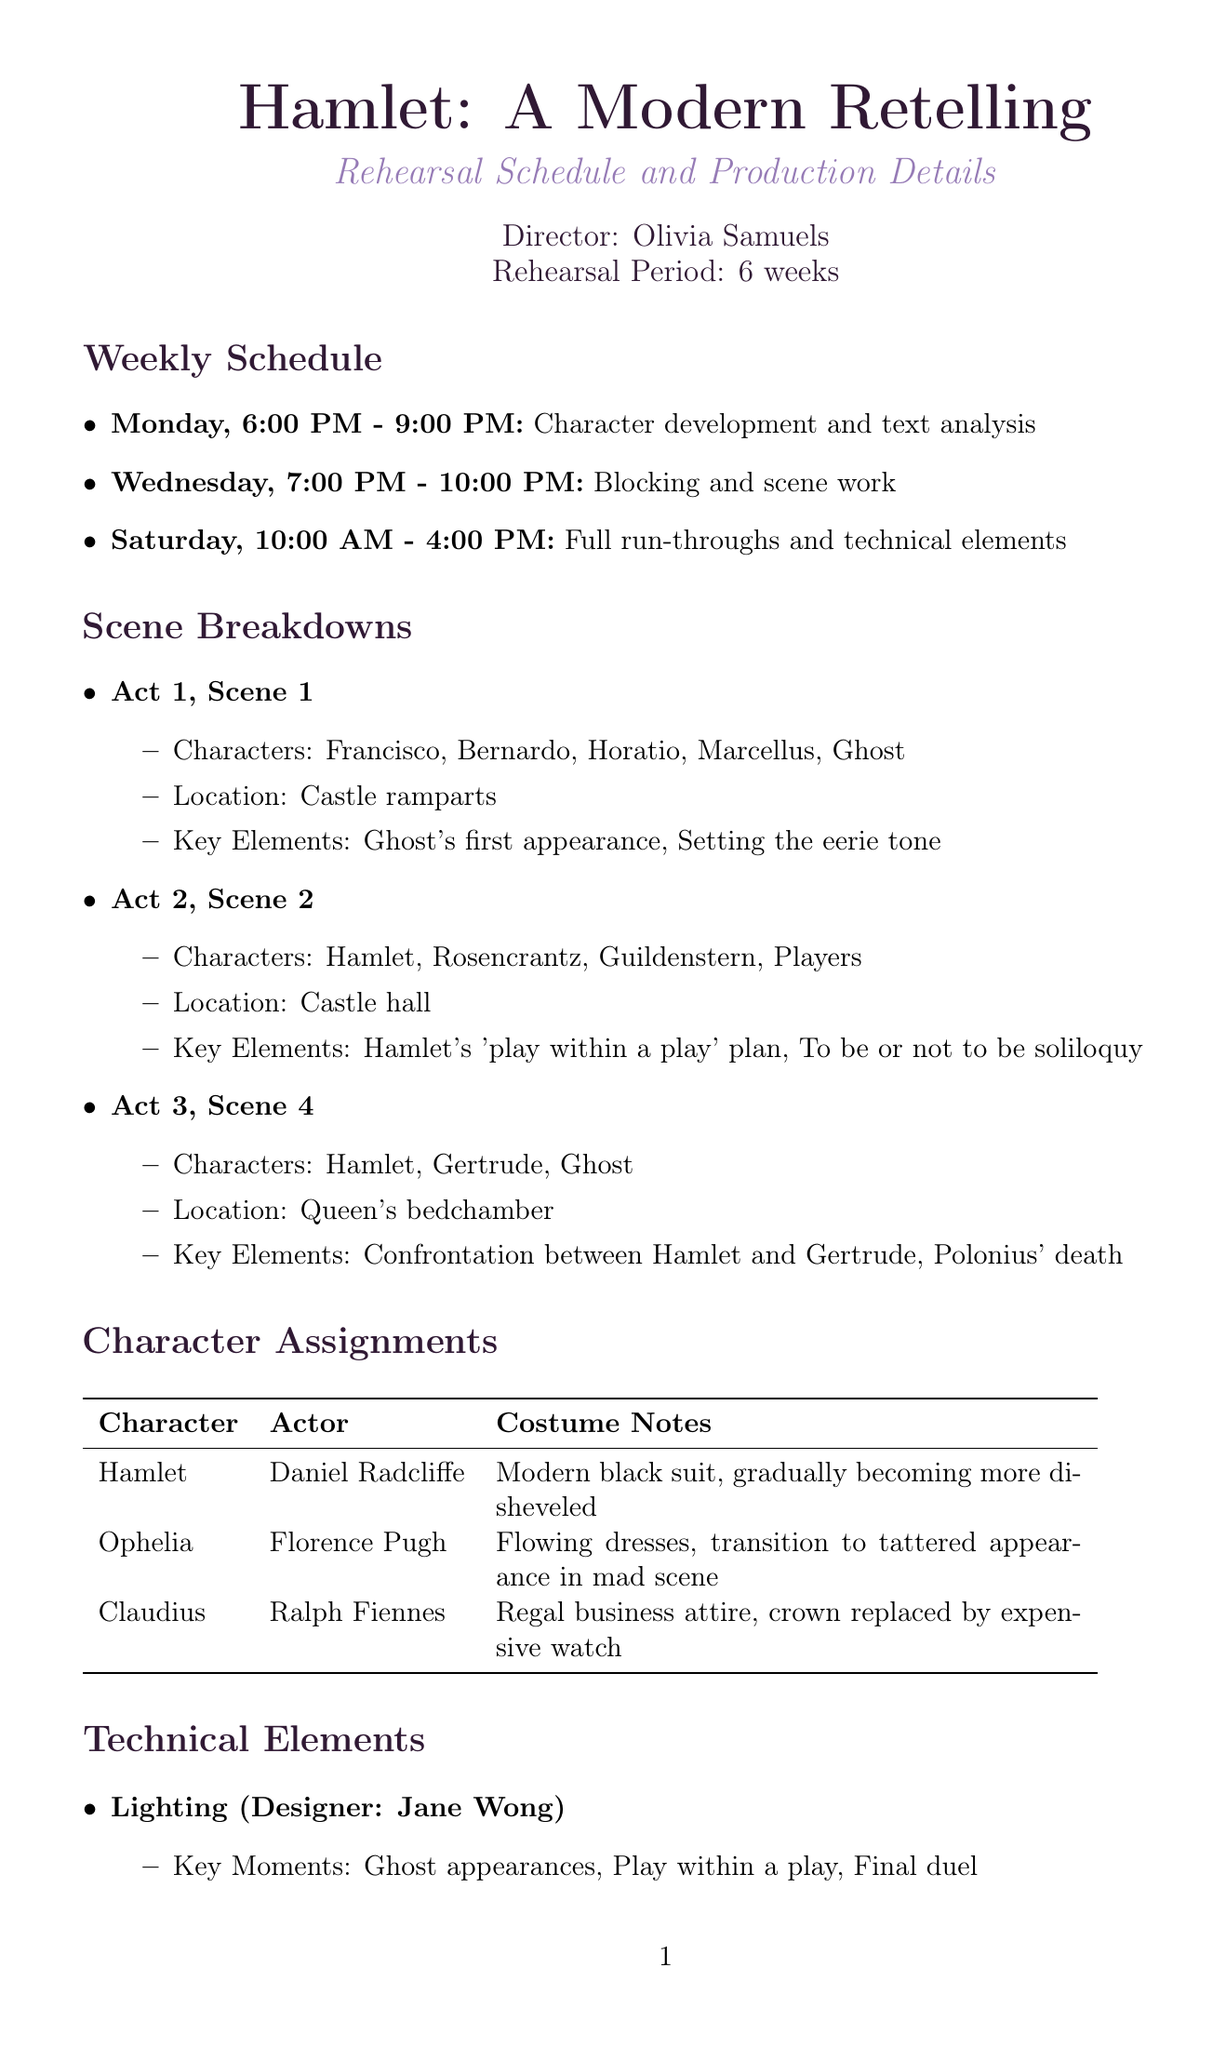What is the production title? The production title is stated at the top of the document as "Hamlet: A Modern Retelling."
Answer: Hamlet: A Modern Retelling Who is the director? The director's name is provided in the header of the document, which is Olivia Samuels.
Answer: Olivia Samuels What day and time are the full run-throughs scheduled? The schedule specifies full run-throughs on Saturday from 10:00 AM to 4:00 PM.
Answer: Saturday, 10:00 AM - 4:00 PM Which character is played by Daniel Radcliffe? The document lists character assignments, specifically identifying "Hamlet" as the character portrayed by Daniel Radcliffe.
Answer: Hamlet What is the key element in Act 1, Scene 1? The document mentions the key elements for Act 1, Scene 1, stating "Ghost's first appearance, Setting the eerie tone."
Answer: Ghost's first appearance How often are fight choreography rehearsals held? The document outlines the special rehearsals, indicating that fight choreography occurs twice a week on Tuesdays and Thursdays.
Answer: Twice a week What costume notes are provided for Ophelia? The costume notes for Ophelia state that she wears "Flowing dresses, transition to tattered appearance in mad scene."
Answer: Flowing dresses, transition to tattered appearance in mad scene Who is the sound designer? The document lists technical elements, naming "Marco Beltrami" as the sound designer.
Answer: Marco Beltrami What is the focus of rehearsals on Mondays? The weekly schedule specifies that Mondays are focused on "Character development and text analysis."
Answer: Character development and text analysis 